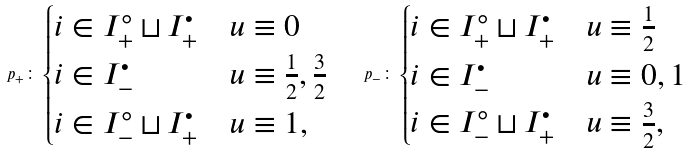Convert formula to latex. <formula><loc_0><loc_0><loc_500><loc_500>p _ { + } \colon \begin{cases} i \in I ^ { \circ } _ { + } \sqcup I ^ { \bullet } _ { + } & u \equiv 0 \\ i \in I ^ { \bullet } _ { - } & u \equiv \frac { 1 } { 2 } , \frac { 3 } { 2 } \\ i \in I ^ { \circ } _ { - } \sqcup I ^ { \bullet } _ { + } & u \equiv 1 , \end{cases} \quad p _ { - } \colon \begin{cases} i \in I ^ { \circ } _ { + } \sqcup I ^ { \bullet } _ { + } & u \equiv \frac { 1 } { 2 } \\ i \in I ^ { \bullet } _ { - } & u \equiv 0 , 1 \\ i \in I ^ { \circ } _ { - } \sqcup I ^ { \bullet } _ { + } & u \equiv \frac { 3 } { 2 } , \end{cases}</formula> 